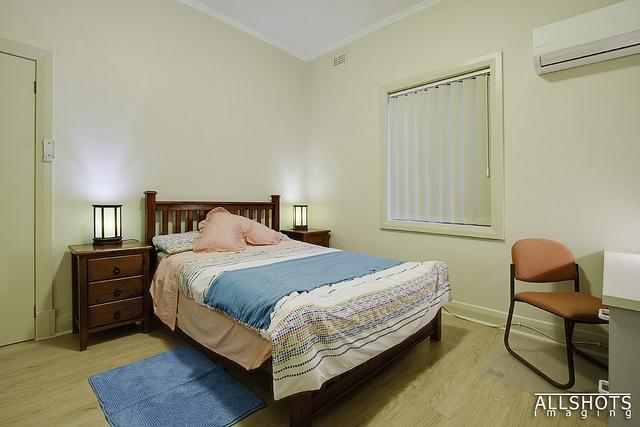Is this likely a basement?
Keep it brief. No. What color is the blanket?
Be succinct. Blue. How many beds do you see?
Short answer required. 1. What kind of room is this?
Keep it brief. Bedroom. Where is the area rug?
Give a very brief answer. To left of bed. Do the pillows match the bed sheet?
Give a very brief answer. Yes. How many beds are there?
Be succinct. 1. 